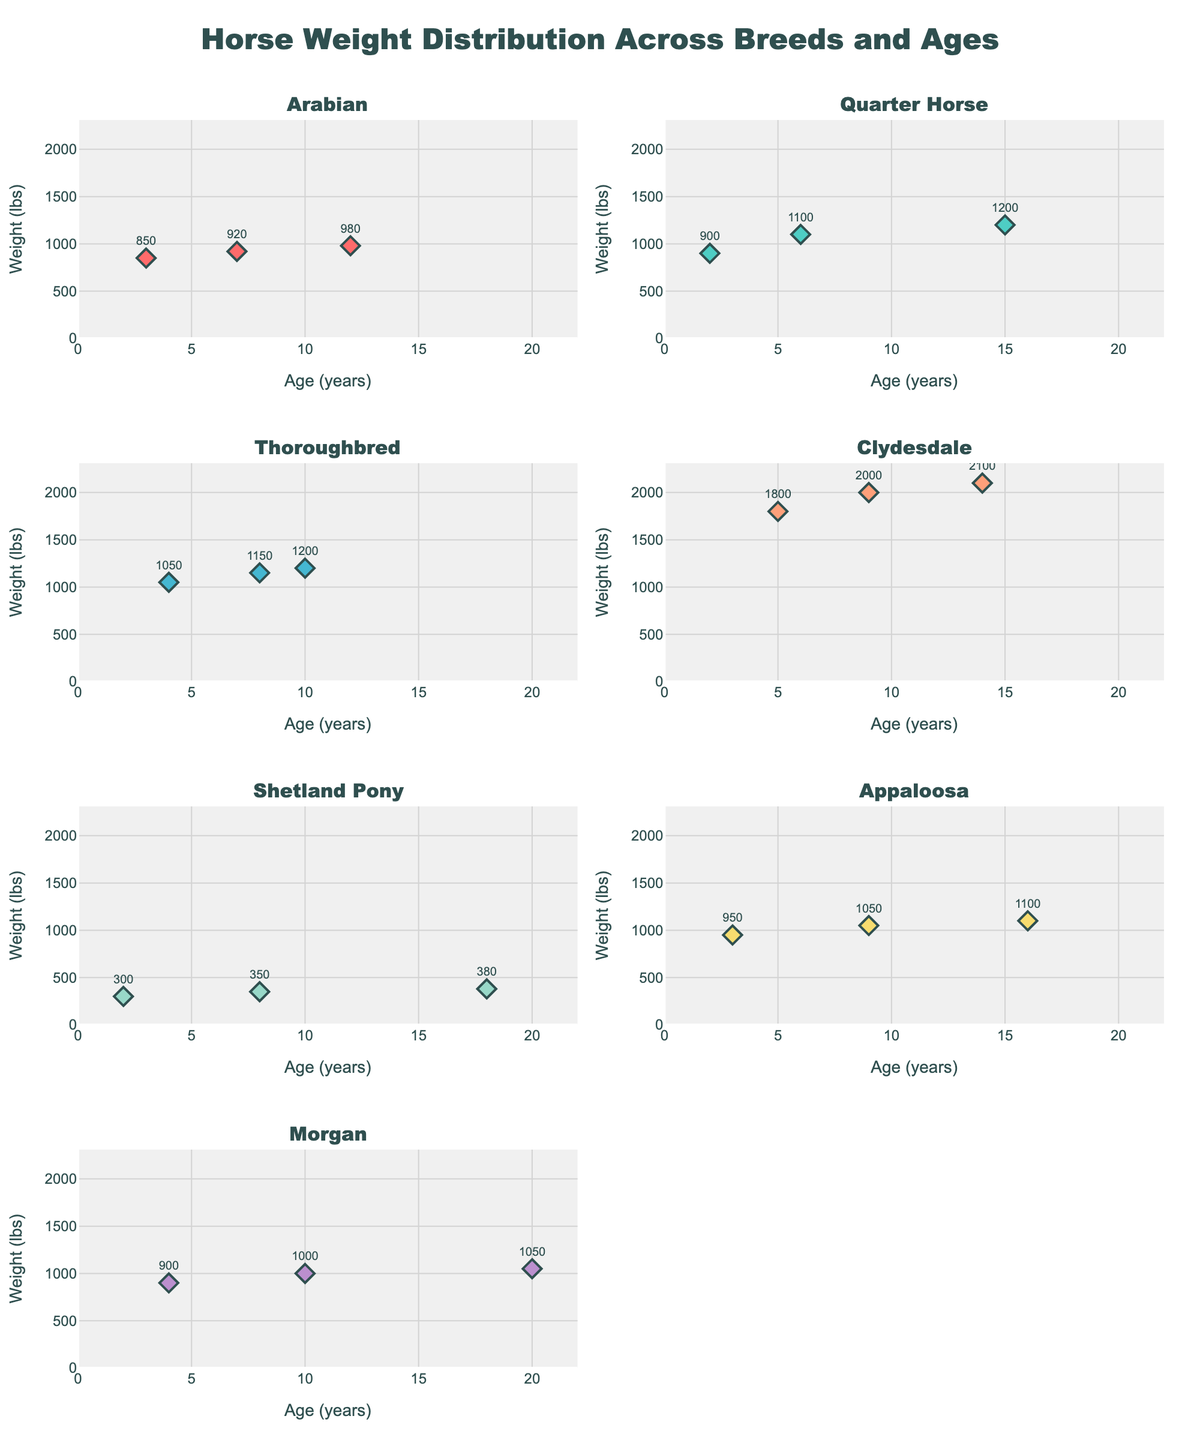What is the title of the figure? The title is located at the top of the figure, presented in a larger font size and centered.
Answer: Horse Weight Distribution Across Breeds and Ages Which breed has the highest weight recorded and what is the weight? The highest weight is visible in the subplot titled with the breed's name. The maximum weight across all subplots is in the "Clydesdale" breed with a weight of 2100 lbs.
Answer: Clydesdale, 2100 lbs How many age and weight points are plotted for the breed "Thoroughbred"? By counting the number of markers in the sub-plot titled "Thoroughbred," you can see three points are plotted.
Answer: 3 What is the range of weights for the breed "Arabian"? By looking at the vertical axis (Weight) in the "Arabian" subplot, the weights appear to be from 850 lbs to 980 lbs.
Answer: 850-980 lbs Which breed shows the most significant weight gain from the youngest to the oldest horse? By comparing the weight increases from the youngest to the oldest ages in each subplot, the "Clydesdale" breed shows the most significant gain from 1800 lbs at age 5 to 2100 lbs at age 14.
Answer: Clydesdale Which breed has the most variation in the weight of horses? The breed with the widest spread of points along the weight axis signals significant variation. "Clydesdale" has weights ranging from 1800 to 2100 lbs, indicating the most variation.
Answer: Clydesdale At what age do "Quarter Horse" horses reach a weight of 1100 lbs? Look for the data point with a weight of 1100 lbs in the "Quarter Horse" subplot; this weight is reached at age 6.
Answer: Age 6 Are there any breeds where the weight of horses decreases with age? In each subplot, trace the trend of the data points against age. All the breeds show either a stable or increasing weight pattern with age, so no breed shows a decrease in weight with age.
Answer: No breeds At age 8, which breed is the heaviest? Look for data points at age 8 across subplots. "Clydesdale" has a weight recorded at this age, which is 2000 lbs.
Answer: Clydesdale Which breed has horses that consistently weigh less than 400 lbs? Scan for subplots with weights consistently below 400 lbs. "Shetland Pony" fits this criterion with weights between 300 and 380 lbs.
Answer: Shetland Pony 